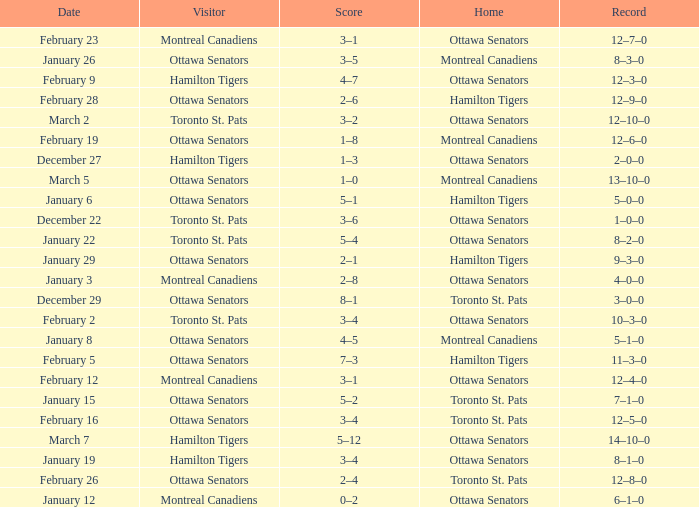What is the score of the game on January 12? 0–2. Can you parse all the data within this table? {'header': ['Date', 'Visitor', 'Score', 'Home', 'Record'], 'rows': [['February 23', 'Montreal Canadiens', '3–1', 'Ottawa Senators', '12–7–0'], ['January 26', 'Ottawa Senators', '3–5', 'Montreal Canadiens', '8–3–0'], ['February 9', 'Hamilton Tigers', '4–7', 'Ottawa Senators', '12–3–0'], ['February 28', 'Ottawa Senators', '2–6', 'Hamilton Tigers', '12–9–0'], ['March 2', 'Toronto St. Pats', '3–2', 'Ottawa Senators', '12–10–0'], ['February 19', 'Ottawa Senators', '1–8', 'Montreal Canadiens', '12–6–0'], ['December 27', 'Hamilton Tigers', '1–3', 'Ottawa Senators', '2–0–0'], ['March 5', 'Ottawa Senators', '1–0', 'Montreal Canadiens', '13–10–0'], ['January 6', 'Ottawa Senators', '5–1', 'Hamilton Tigers', '5–0–0'], ['December 22', 'Toronto St. Pats', '3–6', 'Ottawa Senators', '1–0–0'], ['January 22', 'Toronto St. Pats', '5–4', 'Ottawa Senators', '8–2–0'], ['January 29', 'Ottawa Senators', '2–1', 'Hamilton Tigers', '9–3–0'], ['January 3', 'Montreal Canadiens', '2–8', 'Ottawa Senators', '4–0–0'], ['December 29', 'Ottawa Senators', '8–1', 'Toronto St. Pats', '3–0–0'], ['February 2', 'Toronto St. Pats', '3–4', 'Ottawa Senators', '10–3–0'], ['January 8', 'Ottawa Senators', '4–5', 'Montreal Canadiens', '5–1–0'], ['February 5', 'Ottawa Senators', '7–3', 'Hamilton Tigers', '11–3–0'], ['February 12', 'Montreal Canadiens', '3–1', 'Ottawa Senators', '12–4–0'], ['January 15', 'Ottawa Senators', '5–2', 'Toronto St. Pats', '7–1–0'], ['February 16', 'Ottawa Senators', '3–4', 'Toronto St. Pats', '12–5–0'], ['March 7', 'Hamilton Tigers', '5–12', 'Ottawa Senators', '14–10–0'], ['January 19', 'Hamilton Tigers', '3–4', 'Ottawa Senators', '8–1–0'], ['February 26', 'Ottawa Senators', '2–4', 'Toronto St. Pats', '12–8–0'], ['January 12', 'Montreal Canadiens', '0–2', 'Ottawa Senators', '6–1–0']]} 